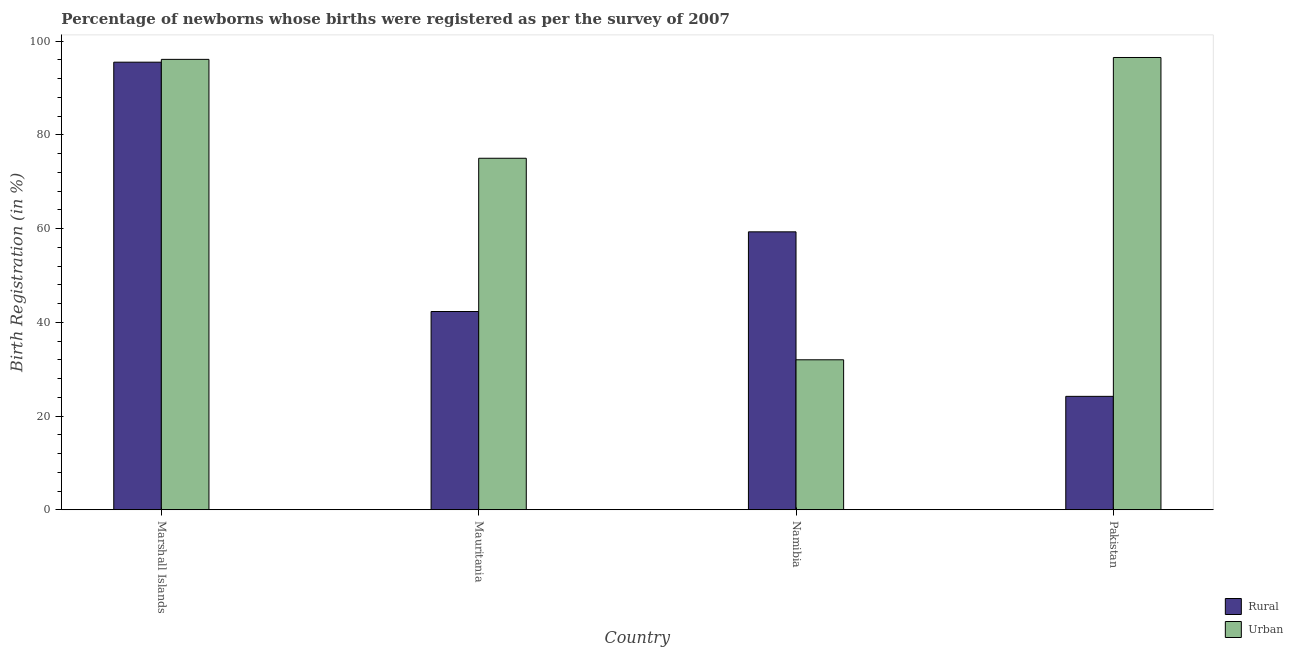How many groups of bars are there?
Provide a short and direct response. 4. Are the number of bars on each tick of the X-axis equal?
Offer a very short reply. Yes. What is the label of the 1st group of bars from the left?
Offer a terse response. Marshall Islands. What is the urban birth registration in Marshall Islands?
Your answer should be compact. 96.1. Across all countries, what is the maximum urban birth registration?
Give a very brief answer. 96.5. Across all countries, what is the minimum rural birth registration?
Make the answer very short. 24.2. In which country was the urban birth registration maximum?
Your answer should be very brief. Pakistan. What is the total urban birth registration in the graph?
Provide a short and direct response. 299.6. What is the difference between the urban birth registration in Marshall Islands and the rural birth registration in Namibia?
Your answer should be very brief. 36.8. What is the average urban birth registration per country?
Make the answer very short. 74.9. What is the difference between the rural birth registration and urban birth registration in Namibia?
Keep it short and to the point. 27.3. What is the ratio of the urban birth registration in Marshall Islands to that in Namibia?
Your answer should be very brief. 3. Is the difference between the rural birth registration in Marshall Islands and Mauritania greater than the difference between the urban birth registration in Marshall Islands and Mauritania?
Offer a terse response. Yes. What is the difference between the highest and the second highest rural birth registration?
Your answer should be compact. 36.2. What is the difference between the highest and the lowest rural birth registration?
Make the answer very short. 71.3. What does the 2nd bar from the left in Mauritania represents?
Offer a very short reply. Urban. What does the 2nd bar from the right in Mauritania represents?
Ensure brevity in your answer.  Rural. How many bars are there?
Offer a terse response. 8. How many countries are there in the graph?
Give a very brief answer. 4. What is the difference between two consecutive major ticks on the Y-axis?
Ensure brevity in your answer.  20. Does the graph contain grids?
Give a very brief answer. No. How many legend labels are there?
Offer a very short reply. 2. How are the legend labels stacked?
Give a very brief answer. Vertical. What is the title of the graph?
Give a very brief answer. Percentage of newborns whose births were registered as per the survey of 2007. What is the label or title of the X-axis?
Your answer should be compact. Country. What is the label or title of the Y-axis?
Provide a succinct answer. Birth Registration (in %). What is the Birth Registration (in %) of Rural in Marshall Islands?
Provide a short and direct response. 95.5. What is the Birth Registration (in %) in Urban in Marshall Islands?
Your answer should be very brief. 96.1. What is the Birth Registration (in %) in Rural in Mauritania?
Your answer should be compact. 42.3. What is the Birth Registration (in %) of Urban in Mauritania?
Give a very brief answer. 75. What is the Birth Registration (in %) in Rural in Namibia?
Provide a succinct answer. 59.3. What is the Birth Registration (in %) of Rural in Pakistan?
Make the answer very short. 24.2. What is the Birth Registration (in %) in Urban in Pakistan?
Make the answer very short. 96.5. Across all countries, what is the maximum Birth Registration (in %) of Rural?
Make the answer very short. 95.5. Across all countries, what is the maximum Birth Registration (in %) of Urban?
Keep it short and to the point. 96.5. Across all countries, what is the minimum Birth Registration (in %) of Rural?
Keep it short and to the point. 24.2. Across all countries, what is the minimum Birth Registration (in %) in Urban?
Give a very brief answer. 32. What is the total Birth Registration (in %) in Rural in the graph?
Your answer should be very brief. 221.3. What is the total Birth Registration (in %) in Urban in the graph?
Offer a very short reply. 299.6. What is the difference between the Birth Registration (in %) of Rural in Marshall Islands and that in Mauritania?
Your answer should be very brief. 53.2. What is the difference between the Birth Registration (in %) in Urban in Marshall Islands and that in Mauritania?
Provide a succinct answer. 21.1. What is the difference between the Birth Registration (in %) in Rural in Marshall Islands and that in Namibia?
Provide a succinct answer. 36.2. What is the difference between the Birth Registration (in %) in Urban in Marshall Islands and that in Namibia?
Keep it short and to the point. 64.1. What is the difference between the Birth Registration (in %) in Rural in Marshall Islands and that in Pakistan?
Ensure brevity in your answer.  71.3. What is the difference between the Birth Registration (in %) in Urban in Marshall Islands and that in Pakistan?
Give a very brief answer. -0.4. What is the difference between the Birth Registration (in %) of Rural in Mauritania and that in Namibia?
Give a very brief answer. -17. What is the difference between the Birth Registration (in %) in Urban in Mauritania and that in Namibia?
Give a very brief answer. 43. What is the difference between the Birth Registration (in %) of Rural in Mauritania and that in Pakistan?
Offer a terse response. 18.1. What is the difference between the Birth Registration (in %) of Urban in Mauritania and that in Pakistan?
Make the answer very short. -21.5. What is the difference between the Birth Registration (in %) of Rural in Namibia and that in Pakistan?
Provide a short and direct response. 35.1. What is the difference between the Birth Registration (in %) of Urban in Namibia and that in Pakistan?
Offer a very short reply. -64.5. What is the difference between the Birth Registration (in %) in Rural in Marshall Islands and the Birth Registration (in %) in Urban in Namibia?
Keep it short and to the point. 63.5. What is the difference between the Birth Registration (in %) in Rural in Mauritania and the Birth Registration (in %) in Urban in Namibia?
Your response must be concise. 10.3. What is the difference between the Birth Registration (in %) in Rural in Mauritania and the Birth Registration (in %) in Urban in Pakistan?
Provide a succinct answer. -54.2. What is the difference between the Birth Registration (in %) of Rural in Namibia and the Birth Registration (in %) of Urban in Pakistan?
Keep it short and to the point. -37.2. What is the average Birth Registration (in %) in Rural per country?
Your response must be concise. 55.33. What is the average Birth Registration (in %) of Urban per country?
Give a very brief answer. 74.9. What is the difference between the Birth Registration (in %) in Rural and Birth Registration (in %) in Urban in Mauritania?
Your answer should be very brief. -32.7. What is the difference between the Birth Registration (in %) in Rural and Birth Registration (in %) in Urban in Namibia?
Your response must be concise. 27.3. What is the difference between the Birth Registration (in %) in Rural and Birth Registration (in %) in Urban in Pakistan?
Provide a short and direct response. -72.3. What is the ratio of the Birth Registration (in %) of Rural in Marshall Islands to that in Mauritania?
Ensure brevity in your answer.  2.26. What is the ratio of the Birth Registration (in %) in Urban in Marshall Islands to that in Mauritania?
Give a very brief answer. 1.28. What is the ratio of the Birth Registration (in %) of Rural in Marshall Islands to that in Namibia?
Your response must be concise. 1.61. What is the ratio of the Birth Registration (in %) in Urban in Marshall Islands to that in Namibia?
Offer a very short reply. 3. What is the ratio of the Birth Registration (in %) in Rural in Marshall Islands to that in Pakistan?
Give a very brief answer. 3.95. What is the ratio of the Birth Registration (in %) of Rural in Mauritania to that in Namibia?
Make the answer very short. 0.71. What is the ratio of the Birth Registration (in %) of Urban in Mauritania to that in Namibia?
Make the answer very short. 2.34. What is the ratio of the Birth Registration (in %) in Rural in Mauritania to that in Pakistan?
Your answer should be very brief. 1.75. What is the ratio of the Birth Registration (in %) in Urban in Mauritania to that in Pakistan?
Provide a succinct answer. 0.78. What is the ratio of the Birth Registration (in %) of Rural in Namibia to that in Pakistan?
Provide a short and direct response. 2.45. What is the ratio of the Birth Registration (in %) in Urban in Namibia to that in Pakistan?
Your answer should be very brief. 0.33. What is the difference between the highest and the second highest Birth Registration (in %) in Rural?
Your answer should be very brief. 36.2. What is the difference between the highest and the second highest Birth Registration (in %) in Urban?
Your answer should be very brief. 0.4. What is the difference between the highest and the lowest Birth Registration (in %) in Rural?
Make the answer very short. 71.3. What is the difference between the highest and the lowest Birth Registration (in %) of Urban?
Your answer should be compact. 64.5. 